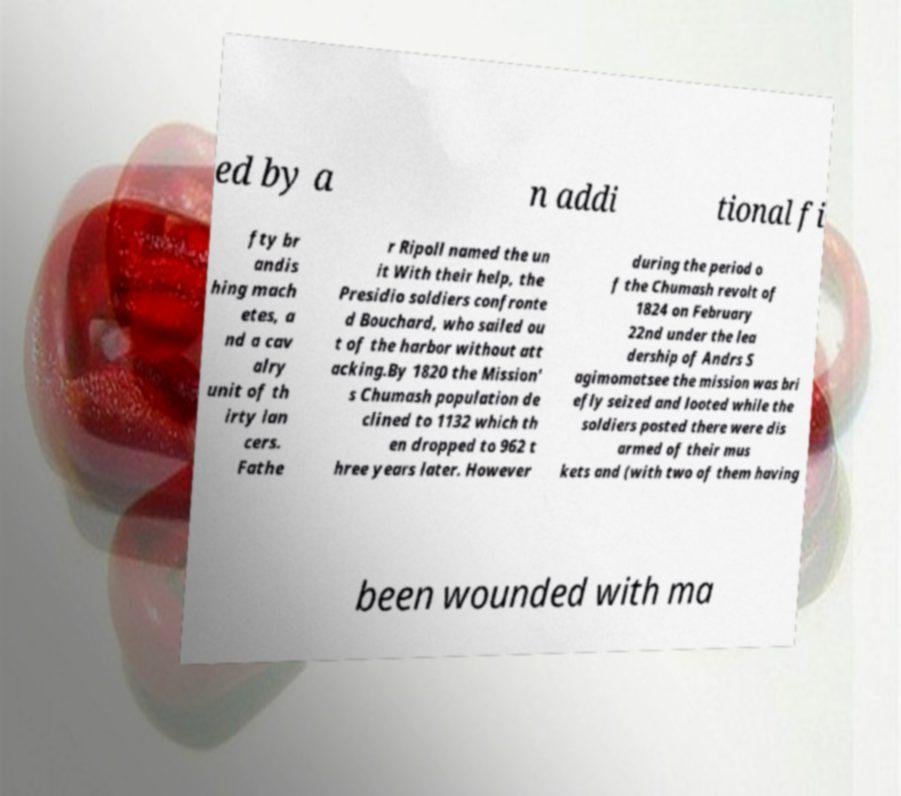Can you read and provide the text displayed in the image?This photo seems to have some interesting text. Can you extract and type it out for me? ed by a n addi tional fi fty br andis hing mach etes, a nd a cav alry unit of th irty lan cers. Fathe r Ripoll named the un it With their help, the Presidio soldiers confronte d Bouchard, who sailed ou t of the harbor without att acking.By 1820 the Mission' s Chumash population de clined to 1132 which th en dropped to 962 t hree years later. However during the period o f the Chumash revolt of 1824 on February 22nd under the lea dership of Andrs S agimomatsee the mission was bri efly seized and looted while the soldiers posted there were dis armed of their mus kets and (with two of them having been wounded with ma 